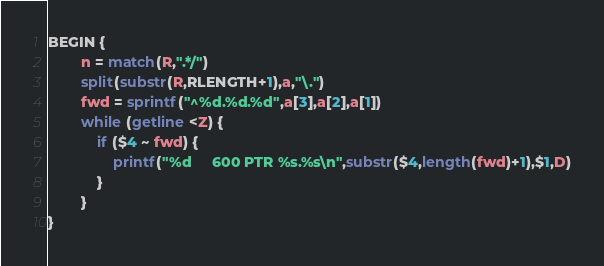Convert code to text. <code><loc_0><loc_0><loc_500><loc_500><_Awk_>
BEGIN {
        n = match(R,".*/")
        split(substr(R,RLENGTH+1),a,"\.")
        fwd = sprintf("^%d.%d.%d",a[3],a[2],a[1])
        while (getline <Z) {
            if ($4 ~ fwd) {
                printf("%d     600 PTR %s.%s\n",substr($4,length(fwd)+1),$1,D)
            }
        }
}
</code> 